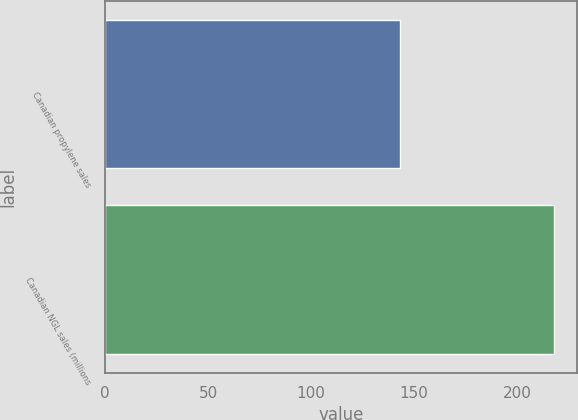Convert chart to OTSL. <chart><loc_0><loc_0><loc_500><loc_500><bar_chart><fcel>Canadian propylene sales<fcel>Canadian NGL sales (millions<nl><fcel>143<fcel>218<nl></chart> 